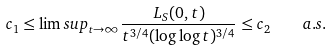Convert formula to latex. <formula><loc_0><loc_0><loc_500><loc_500>c _ { 1 } \leq \lim s u p _ { t \to \infty } \frac { L _ { S } ( 0 , t ) } { t ^ { 3 / 4 } ( \log \log t ) ^ { 3 / 4 } } \leq c _ { 2 } \quad a . s .</formula> 